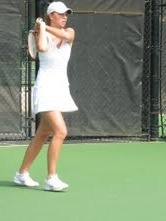Describe the objects in this image and their specific colors. I can see people in gray, white, and tan tones and tennis racket in gray, darkgray, and lightgray tones in this image. 